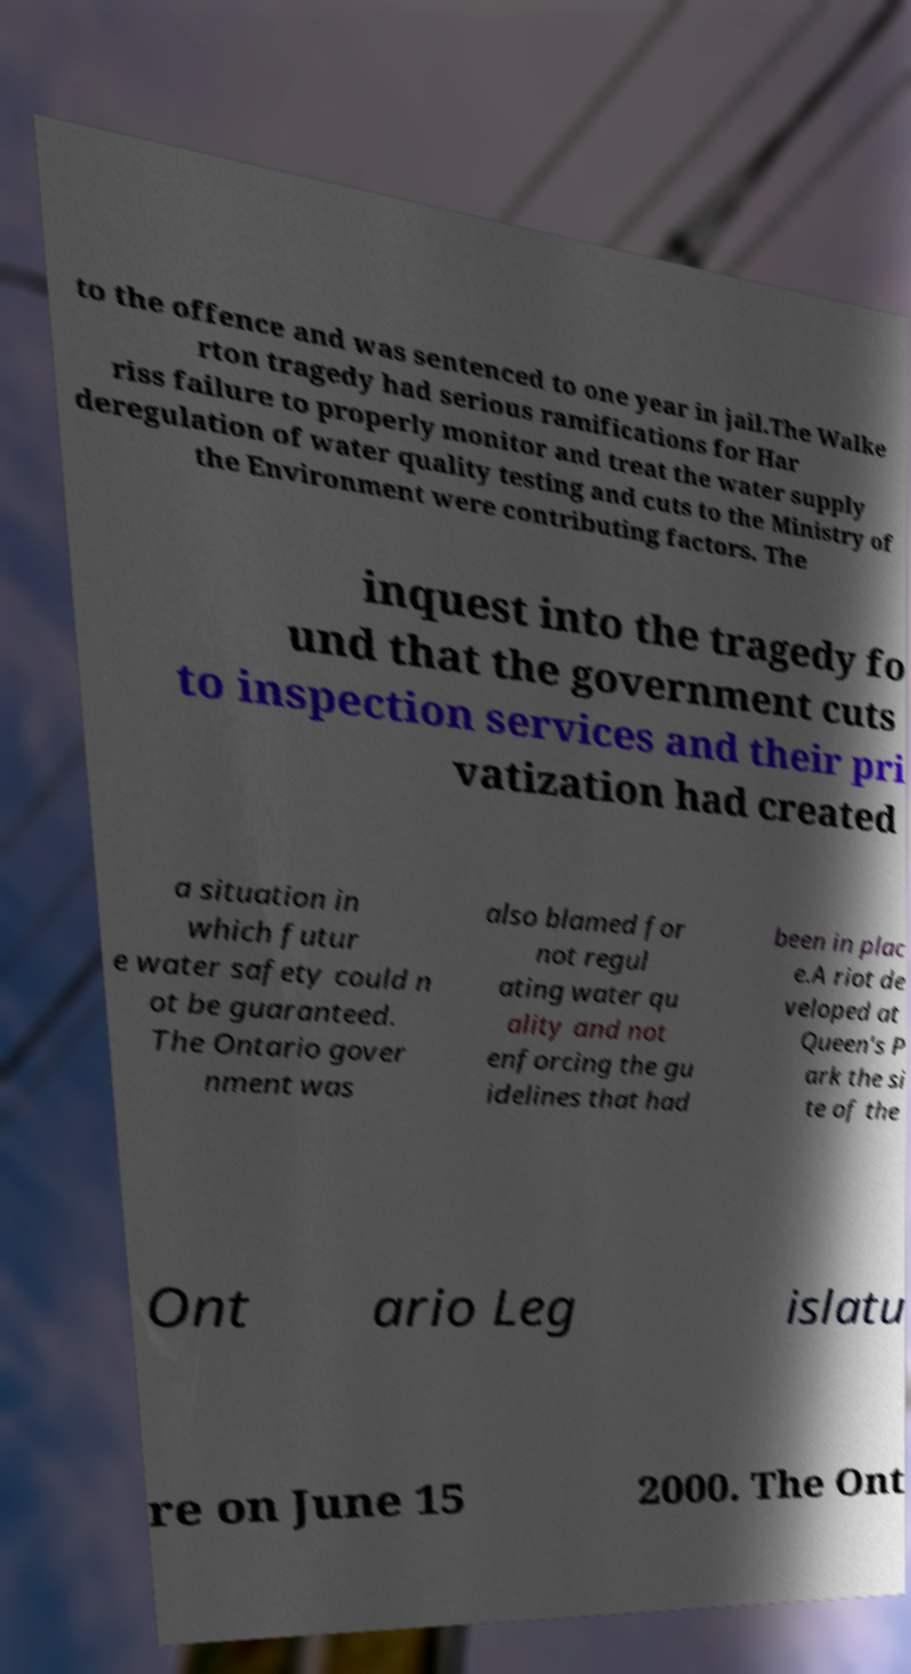Could you extract and type out the text from this image? to the offence and was sentenced to one year in jail.The Walke rton tragedy had serious ramifications for Har riss failure to properly monitor and treat the water supply deregulation of water quality testing and cuts to the Ministry of the Environment were contributing factors. The inquest into the tragedy fo und that the government cuts to inspection services and their pri vatization had created a situation in which futur e water safety could n ot be guaranteed. The Ontario gover nment was also blamed for not regul ating water qu ality and not enforcing the gu idelines that had been in plac e.A riot de veloped at Queen's P ark the si te of the Ont ario Leg islatu re on June 15 2000. The Ont 